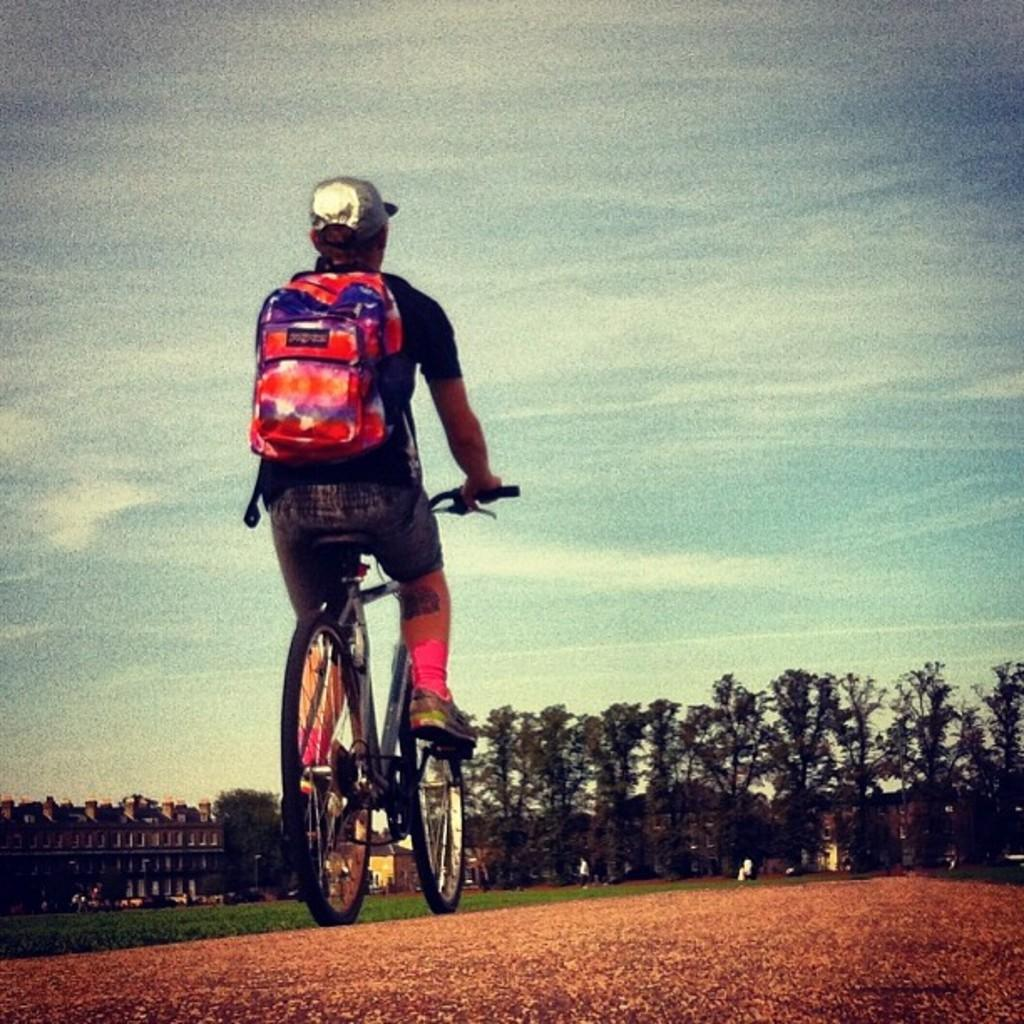Who or what is the main subject in the image? There is a person in the image. What is the person doing in the image? The person is sitting on a bicycle. What can be seen in front of the person? There are trees in front of the person. What is the condition of the sky in the image? The sky is clear in the image. What type of shock can be seen affecting the person in the image? There is no shock present in the image; the person is simply sitting on a bicycle. What color is the yarn used to create the person's clothing in the image? There is no yarn present in the image, as the person is a real individual and not a knitted or crocheted figure. 